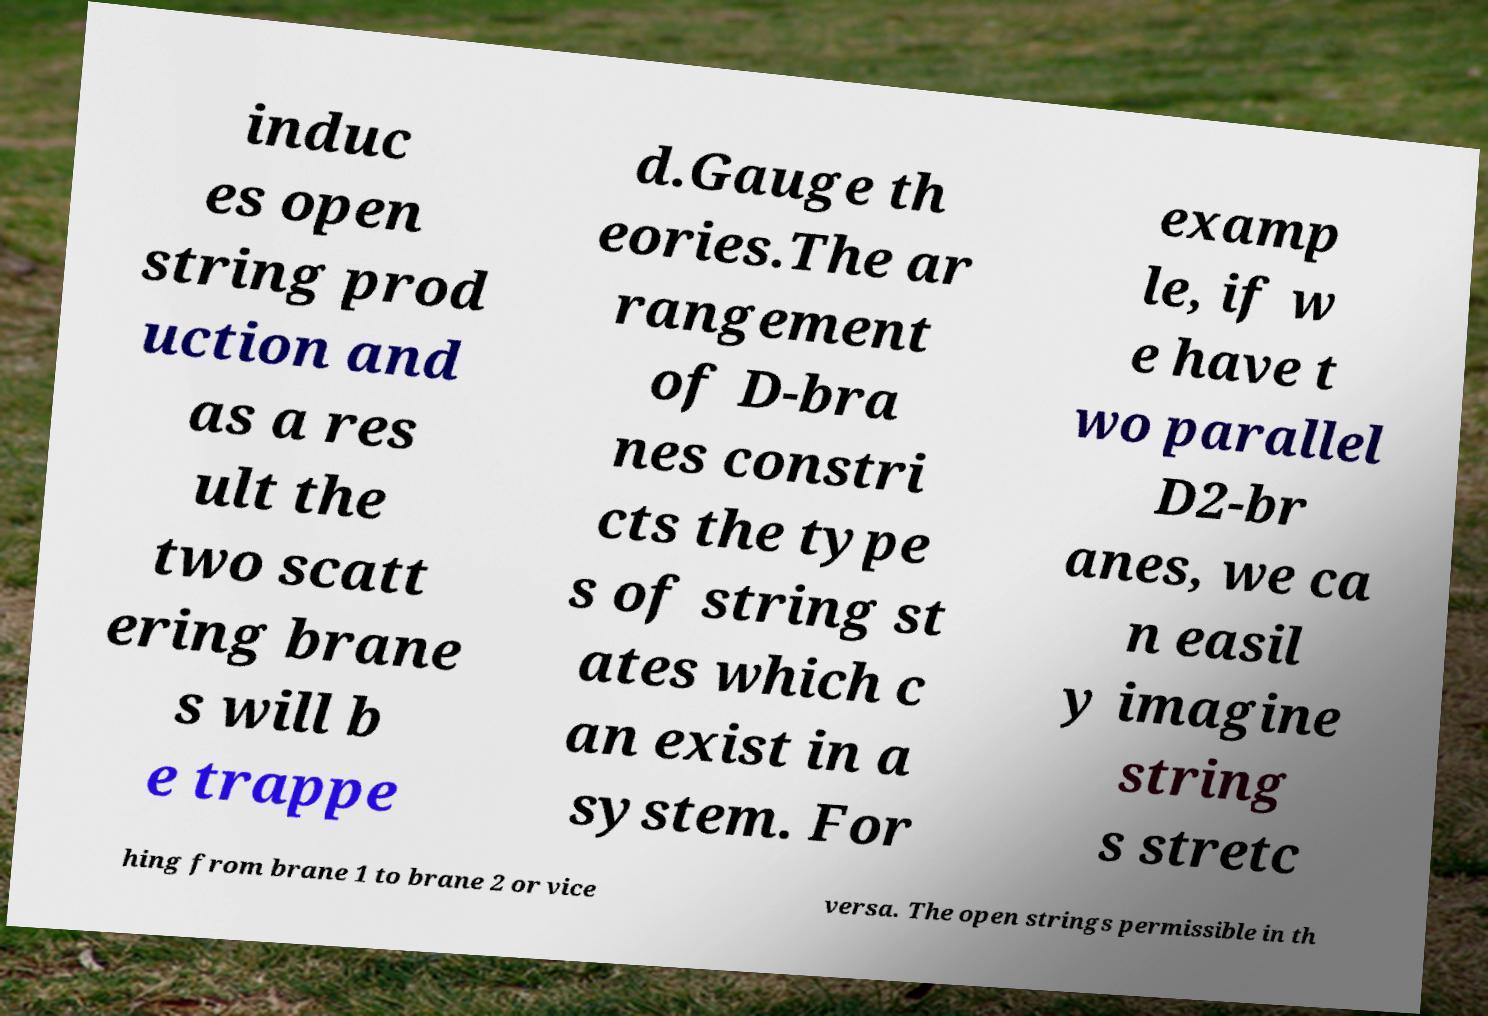There's text embedded in this image that I need extracted. Can you transcribe it verbatim? induc es open string prod uction and as a res ult the two scatt ering brane s will b e trappe d.Gauge th eories.The ar rangement of D-bra nes constri cts the type s of string st ates which c an exist in a system. For examp le, if w e have t wo parallel D2-br anes, we ca n easil y imagine string s stretc hing from brane 1 to brane 2 or vice versa. The open strings permissible in th 